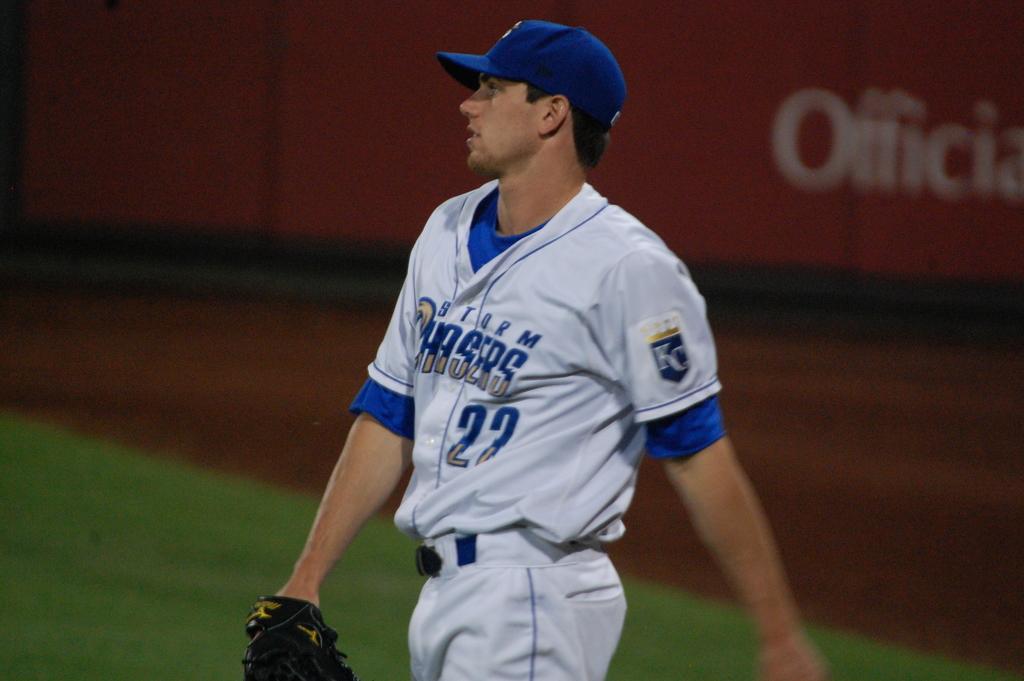What team is this player on?
Your response must be concise. Storm chasers. 